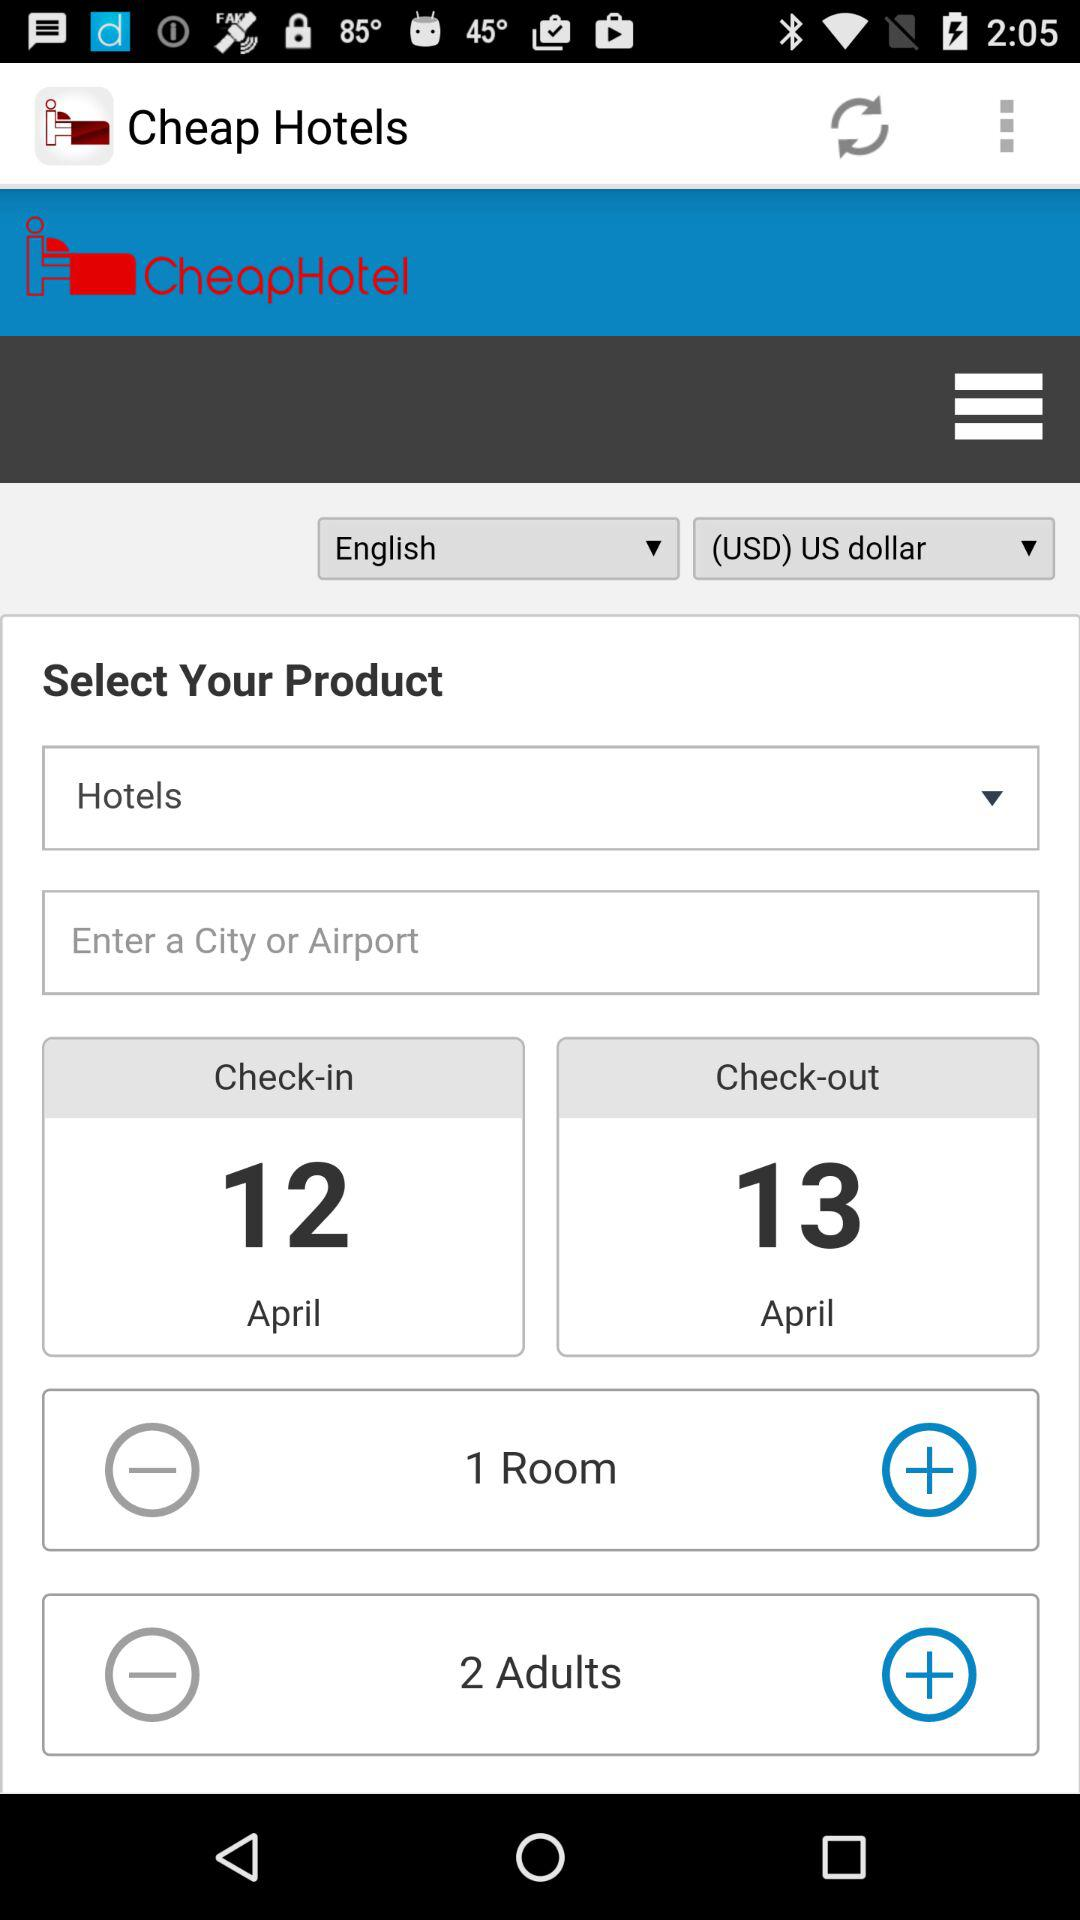What is the app name? The app name is "Cheap Hotels". 